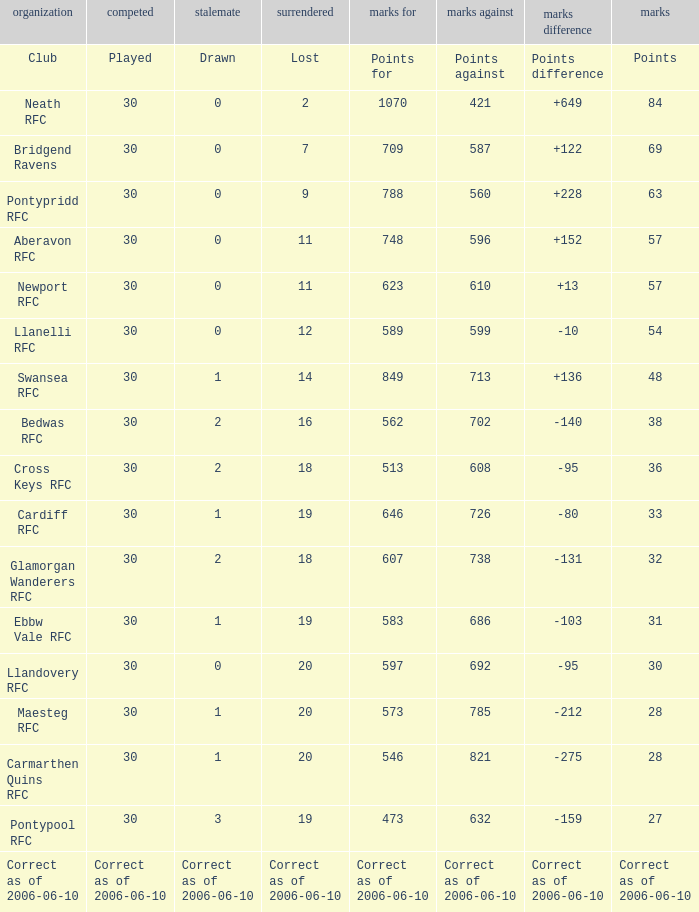What is Drawn, when Points Against is "686"? 1.0. 